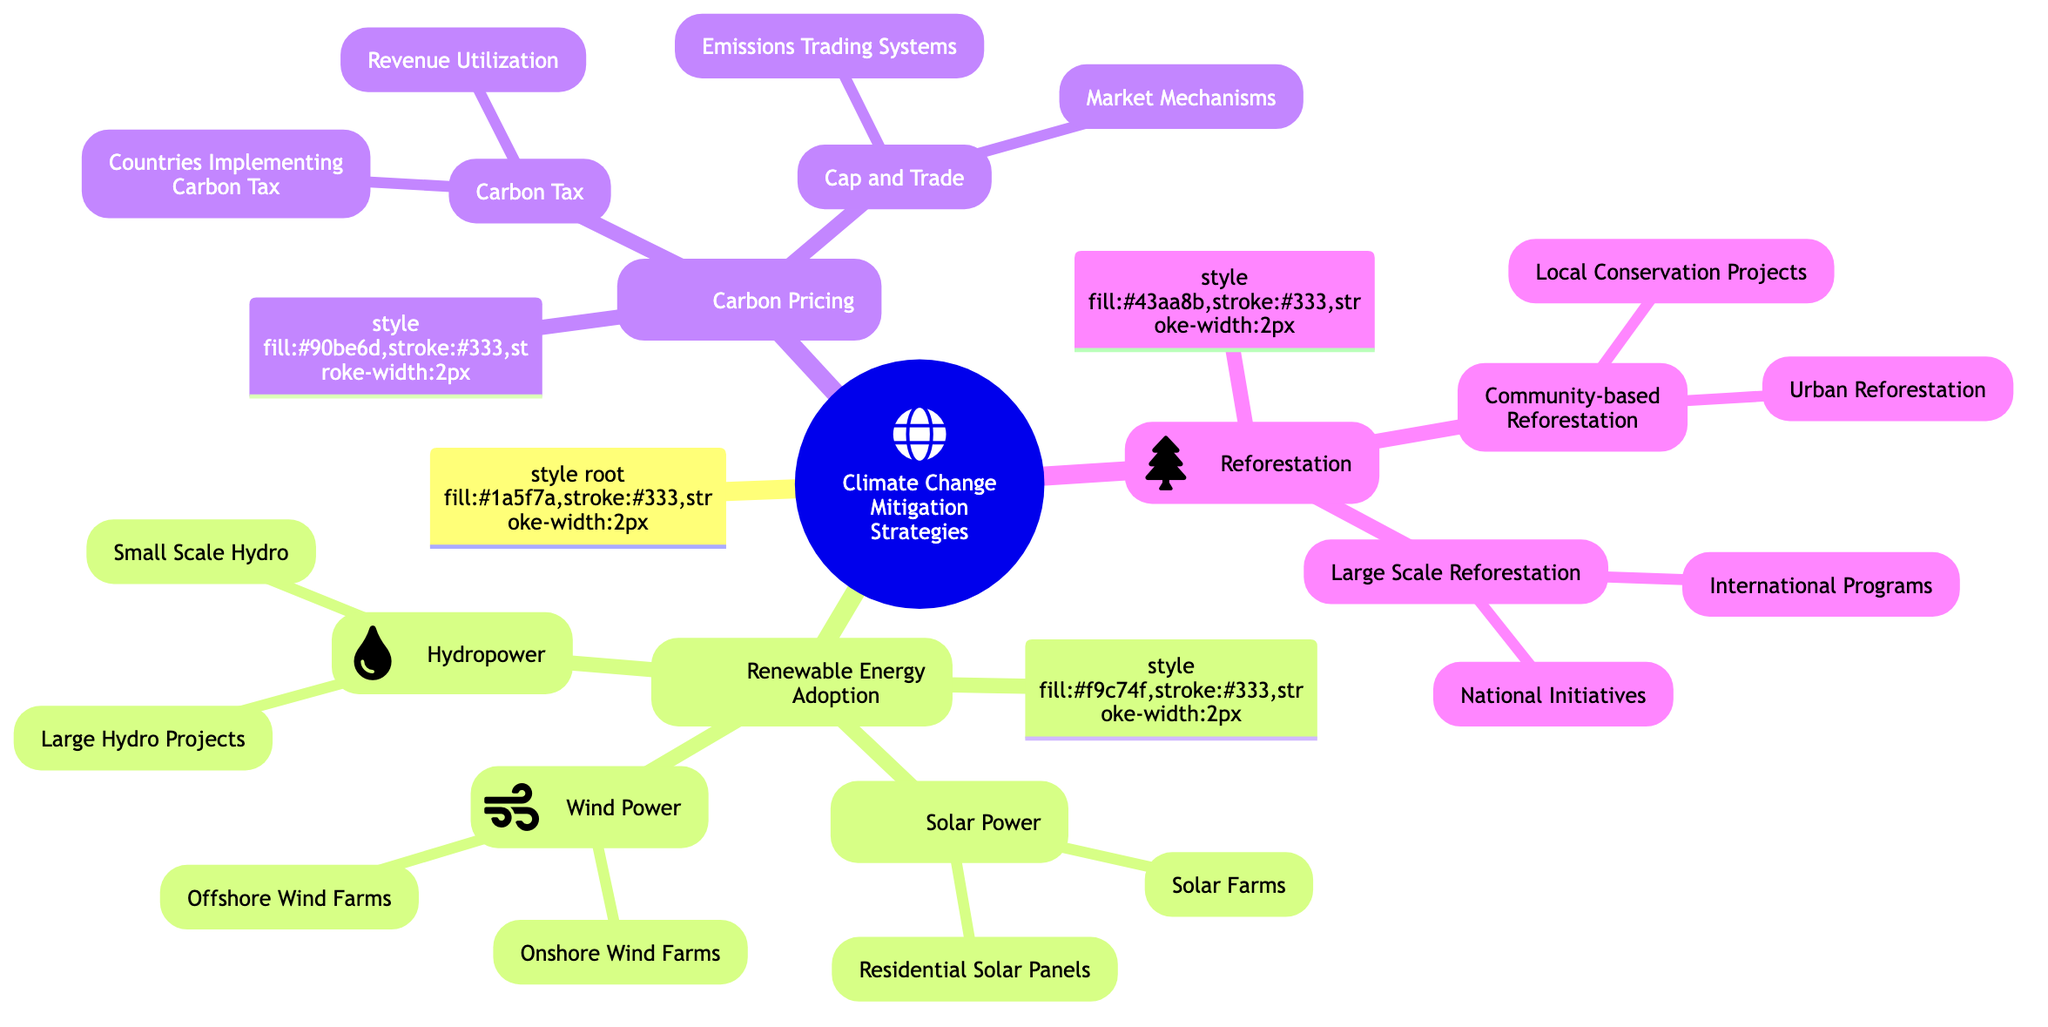What are the three main categories of Climate Change Mitigation Strategies? The diagram outlines three main categories: Renewable Energy Adoption, Carbon Pricing, and Reforestation. These categories are positioned as the primary branches of the mind map.
Answer: Renewable Energy Adoption, Carbon Pricing, Reforestation How many subcategories are under Renewable Energy Adoption? The Renewable Energy Adoption category has three subcategories: Solar Power, Wind Power, and Hydropower. These are the next level of branches connecting to the main category.
Answer: 3 Which type of wind power is implemented in the Texas Wind Corridor? The diagram specifies that Onshore Wind Farms, which are land-based wind turbines, are implemented in the Texas Wind Corridor. This information is found under the Wind Power subcategory.
Answer: Onshore Wind Farms What is one example of a community-based reforestation project? The diagram lists Community-based Reforestation as having Local Conservation Projects as one example, specifically mentioning agroforestry practices in Kenya as an illustration of this type of project.
Answer: Local Conservation Projects What are two methods of carbon pricing? The diagram indicates two methods within the Carbon Pricing category: Carbon Tax and Cap and Trade. These could be identified as distinct branches under the main category.
Answer: Carbon Tax, Cap and Trade How does revenue from carbon tax get utilized? In the Carbon Tax subcategory, the diagram shows that revenue is utilized for investing in renewable energy projects and energy efficiency programs. This describes the purpose of the carbon tax revenue.
Answer: Investing in renewable energy projects How are international reforestation efforts represented in the diagram? The Large Scale Reforestation subcategory lists International Programs as one aspect, specifically highlighting the United Nations' Billion Tree Campaign. This shows the global scale of reforestation initiatives.
Answer: International Programs What is a distinguishing feature of the Cap and Trade system? The diagram indicates that the Cap and Trade method involves Market Mechanisms where companies are allowed to buy and sell emission allowances. This highlights a key characteristic of this carbon pricing strategy.
Answer: Market Mechanisms 